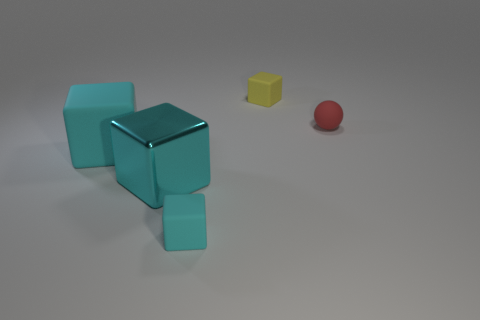How many cyan cubes must be subtracted to get 1 cyan cubes? 2 Subtract all shiny cubes. How many cubes are left? 3 Add 1 large green balls. How many objects exist? 6 Subtract all cyan cubes. How many cubes are left? 1 Subtract all spheres. How many objects are left? 4 Subtract all green blocks. Subtract all blue spheres. How many blocks are left? 4 Subtract all green cylinders. How many cyan cubes are left? 3 Subtract all matte balls. Subtract all matte things. How many objects are left? 0 Add 2 tiny cyan things. How many tiny cyan things are left? 3 Add 5 small brown metal things. How many small brown metal things exist? 5 